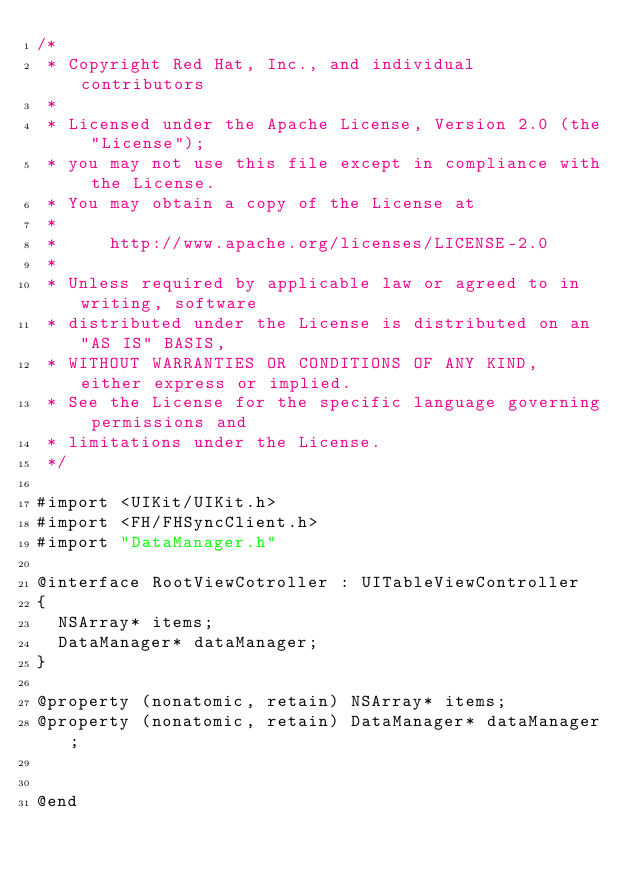<code> <loc_0><loc_0><loc_500><loc_500><_C_>/*
 * Copyright Red Hat, Inc., and individual contributors
 *
 * Licensed under the Apache License, Version 2.0 (the "License");
 * you may not use this file except in compliance with the License.
 * You may obtain a copy of the License at
 *
 *     http://www.apache.org/licenses/LICENSE-2.0
 *
 * Unless required by applicable law or agreed to in writing, software
 * distributed under the License is distributed on an "AS IS" BASIS,
 * WITHOUT WARRANTIES OR CONDITIONS OF ANY KIND, either express or implied.
 * See the License for the specific language governing permissions and
 * limitations under the License.
 */

#import <UIKit/UIKit.h>
#import <FH/FHSyncClient.h>
#import "DataManager.h"

@interface RootViewCotroller : UITableViewController
{
  NSArray* items;
  DataManager* dataManager;
}

@property (nonatomic, retain) NSArray* items;
@property (nonatomic, retain) DataManager* dataManager;


@end
</code> 